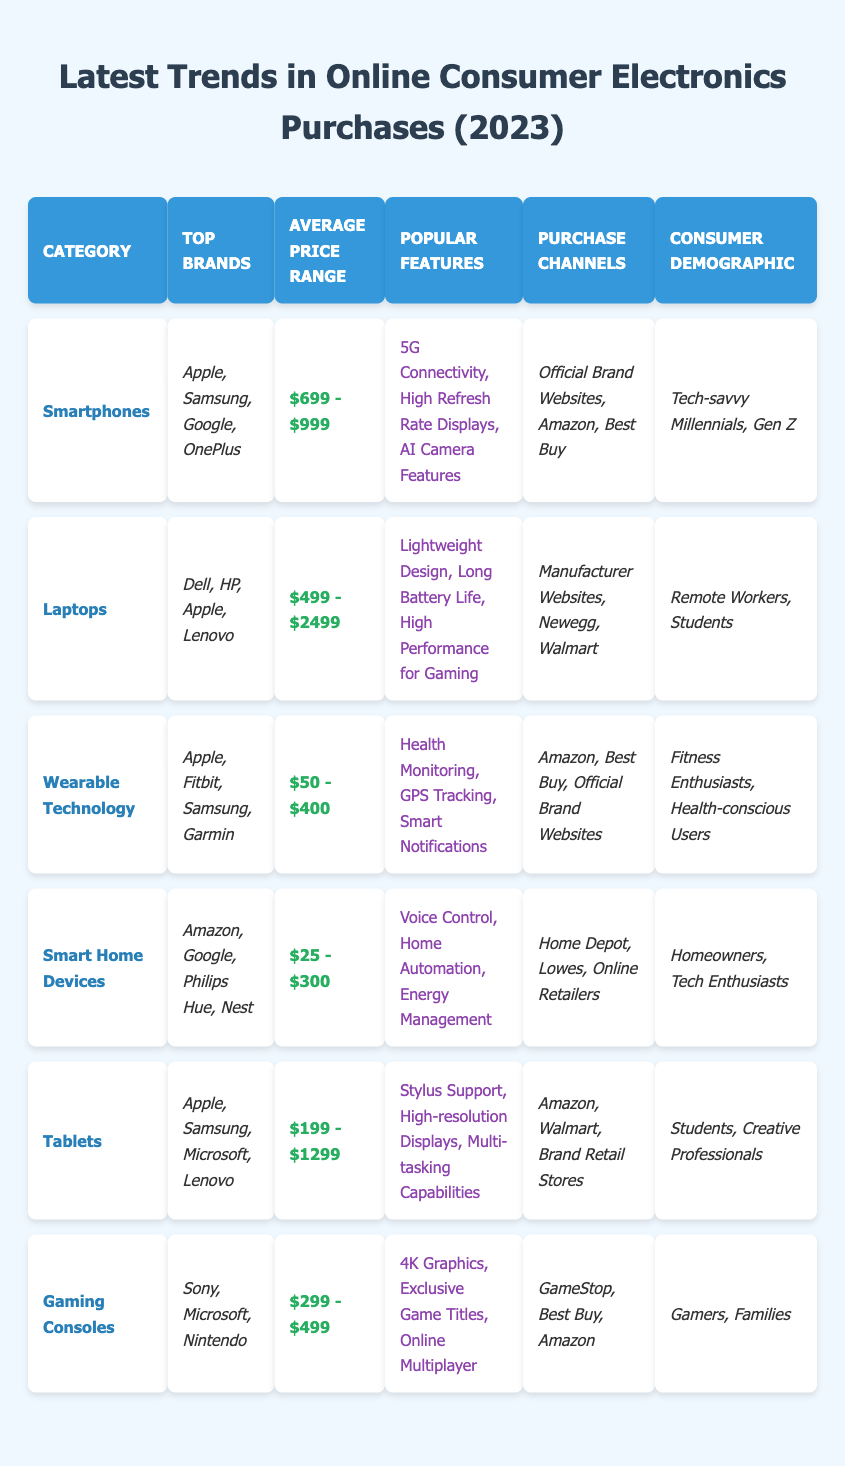What are the top brands for Laptops? The table lists Dell, HP, Apple, and Lenovo as the top brands under the Laptops category.
Answer: Dell, HP, Apple, Lenovo What is the average price range for Smart Home Devices? The table shows the average price range for Smart Home Devices is from $25 to $300.
Answer: $25 - $300 Which category has the highest average price range? By comparing the average price ranges, Laptops have the highest average price range of $499 to $2499.
Answer: Laptops Are all the top brands for Wearable Technology also found in the Smartphones category? The top brands for Wearable Technology are Apple, Fitbit, Samsung, and Garmin. Since Apple and Samsung are also top brands in the Smartphones category, it is true that some brands overlap, but Fitbit and Garmin are not found in Smartphones.
Answer: No What features are popular among Tablets? The popular features listed for Tablets in the table are Stylus Support, High-resolution Displays, and Multi-tasking Capabilities.
Answer: Stylus Support, High-resolution Displays, Multi-tasking Capabilities Is the average price range of Gaming Consoles lower than that of Smartphones? Gaming Consoles have an average price range of $299 to $499, while Smartphones range from $699 to $999. Since $299 is less than $699, this statement is true.
Answer: Yes How many different consumer demographics are identified for Smart Home Devices? For Smart Home Devices, the table lists two demographics: Homeowners and Tech Enthusiasts. Counting them gives us a total of two distinct demographics.
Answer: 2 What is the common purchase channel for both Tablets and Laptops? Tablets and Laptops share Amazon as a common purchase channel. By checking both lists, Amazon appears in both categories.
Answer: Amazon Which category has the most diverse demographic profile? Computing the number of demographics for each category shows that Wearable Technology lists two while Gaming Consoles lists two as well; however, Laptops has two demographics but they are somewhat more varied being 'Remote Workers' and 'Students'. The complex reasoning shows Tablets' demographics are limited to Students and Creative Professionals, making it less diverse. The conclusion is drawn that Laptops provide a more extensive demographic appeal.
Answer: Laptops What are the purchase channels for Smartphones? The table lists Official Brand Websites, Amazon, and Best Buy as the purchase channels for Smartphones.
Answer: Official Brand Websites, Amazon, Best Buy 